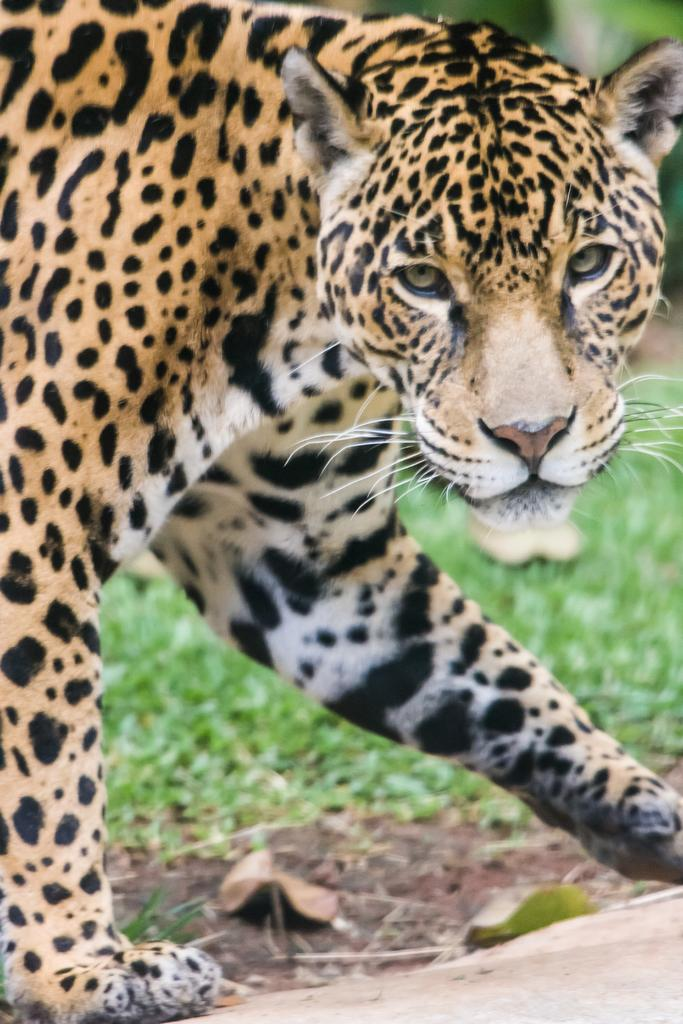Where was the image taken? The image was taken outdoors. What can be seen at the bottom of the image? There is a road at the bottom of the image. What type of ground is visible in the background? There is a ground with grass in the background. What animal is in the middle of the image? There is a leopard in the middle of the image. What type of music is playing in the background of the image? There is no music playing in the background of the image. Can you see a scarecrow in the image? No, there is no scarecrow present in the image. 